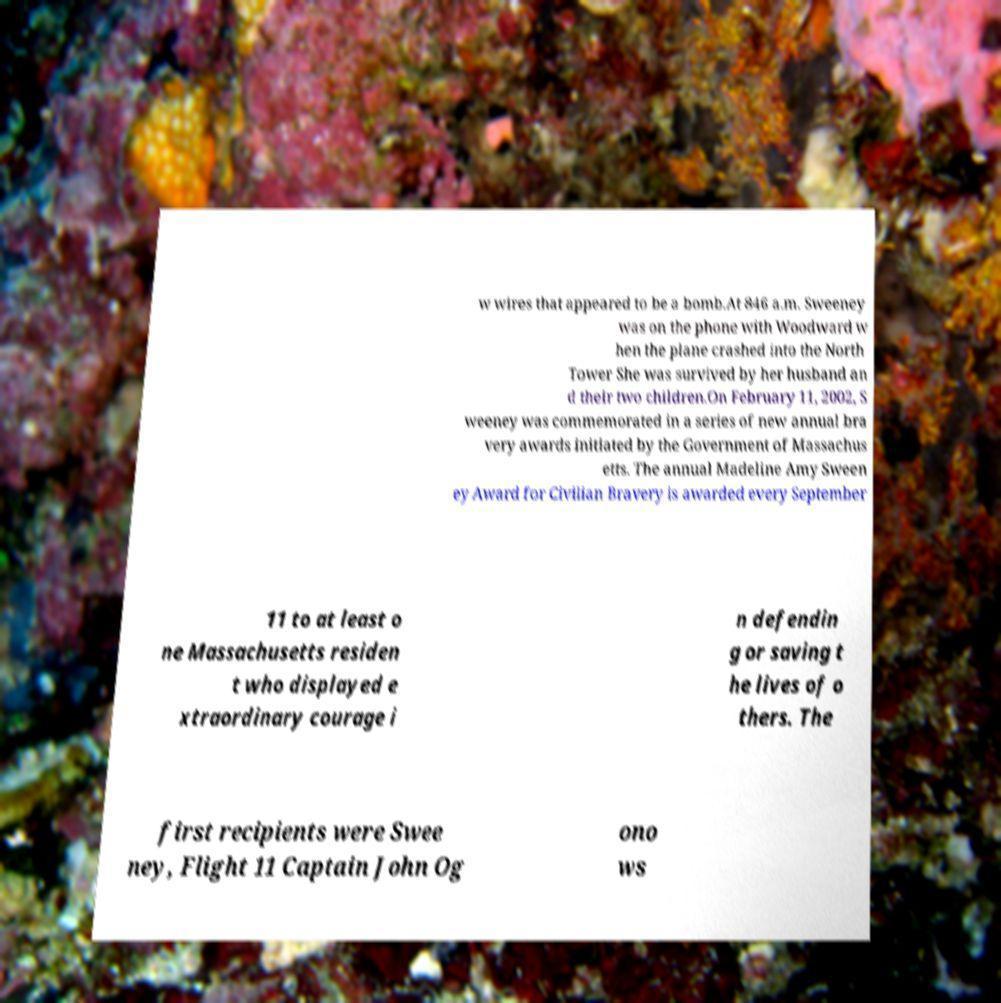Can you read and provide the text displayed in the image?This photo seems to have some interesting text. Can you extract and type it out for me? w wires that appeared to be a bomb.At 846 a.m. Sweeney was on the phone with Woodward w hen the plane crashed into the North Tower She was survived by her husband an d their two children.On February 11, 2002, S weeney was commemorated in a series of new annual bra very awards initiated by the Government of Massachus etts. The annual Madeline Amy Sween ey Award for Civilian Bravery is awarded every September 11 to at least o ne Massachusetts residen t who displayed e xtraordinary courage i n defendin g or saving t he lives of o thers. The first recipients were Swee ney, Flight 11 Captain John Og ono ws 